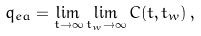<formula> <loc_0><loc_0><loc_500><loc_500>q _ { e a } = \lim _ { t \to \infty } \lim _ { t _ { w } \to \infty } C ( t , t _ { w } ) \, ,</formula> 